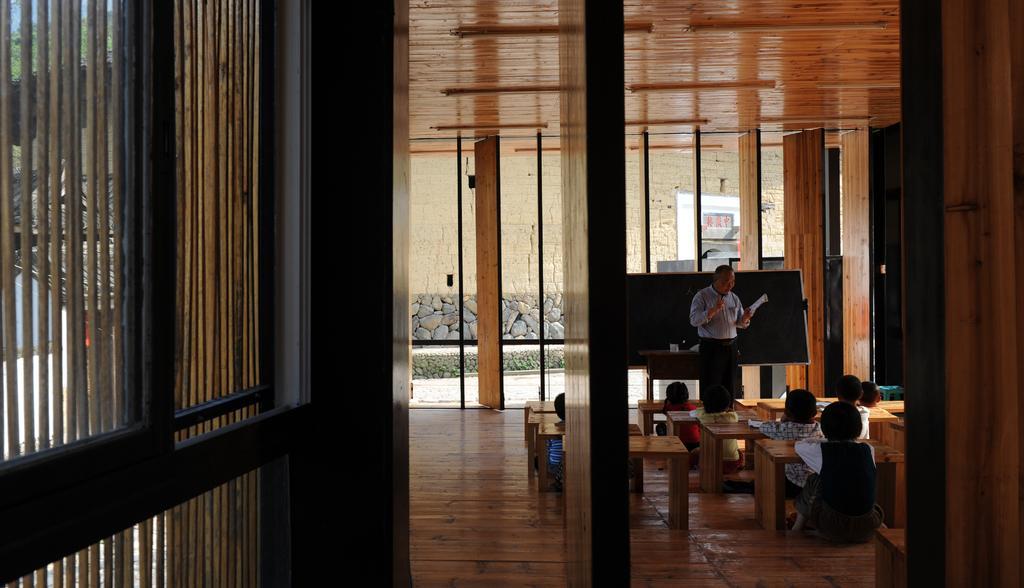In one or two sentences, can you explain what this image depicts? In this image there are few students sitting in front of wooden benches in the class, a teacher holding a book, there are some objects on the table, a blackboard, few buildings and windows. 